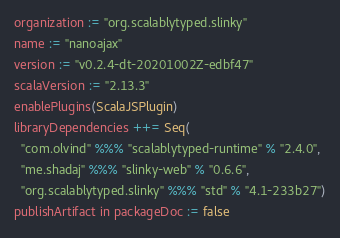<code> <loc_0><loc_0><loc_500><loc_500><_Scala_>organization := "org.scalablytyped.slinky"
name := "nanoajax"
version := "v0.2.4-dt-20201002Z-edbf47"
scalaVersion := "2.13.3"
enablePlugins(ScalaJSPlugin)
libraryDependencies ++= Seq(
  "com.olvind" %%% "scalablytyped-runtime" % "2.4.0",
  "me.shadaj" %%% "slinky-web" % "0.6.6",
  "org.scalablytyped.slinky" %%% "std" % "4.1-233b27")
publishArtifact in packageDoc := false</code> 